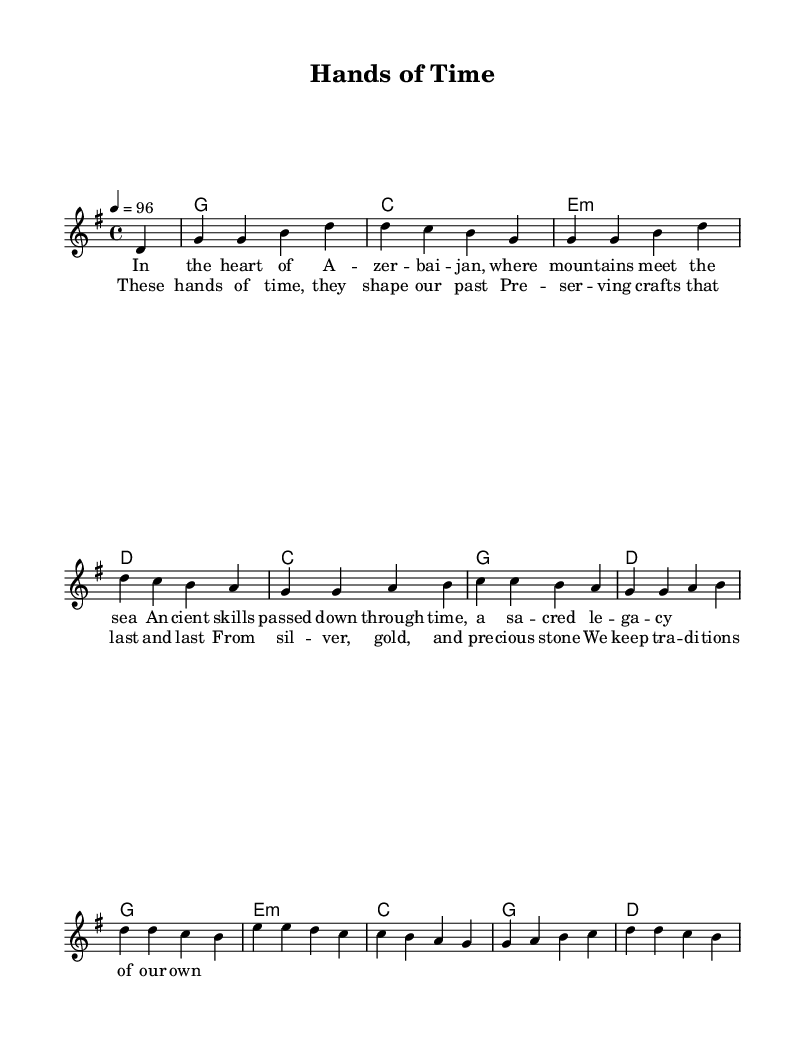What is the key signature of this music? The key signature is G major, which has one sharp (F#). This can be identified by looking at the key signature symbol at the beginning of the staff.
Answer: G major What is the time signature of this music? The time signature is 4/4, which indicates that there are four beats in each measure and the quarter note gets one beat. This is evident from the notation at the beginning of the score.
Answer: 4/4 What is the tempo marking for this piece? The tempo marking is 4 = 96, which indicates that there are 96 quarter note beats per minute. This information is found in the tempo indication near the start of the score.
Answer: 96 How many verses are in this song? There is one verse present in the sheet music indicated by the lyric syllables under the melody. The presence of just one section of lyrics supports that there is only a single verse.
Answer: 1 What are the main themes expressed in the lyrics? The primary themes are preserving traditional crafts and passing down skills. These themes can be deduced from the lyrics that reference ancient skills and a legacy throughout time.
Answer: Traditional crafts What instruments are indicated to perform this piece? The sheet music indicates a lead voice along with chord names for accompaniment. This can be seen from the different parts labeled in the score such as "lead" for the melody and "ChordNames" for the harmonic support.
Answer: Voice and chords What genre does this piece represent? The genre is Country Rock, which is characterized by a blend of traditional country themes with rock elements. This can be inferred from the overall structure, style, and lyrical content focused on crafts and heritage.
Answer: Country Rock 